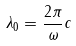<formula> <loc_0><loc_0><loc_500><loc_500>\lambda _ { 0 } = \frac { 2 \pi } { \omega } c</formula> 